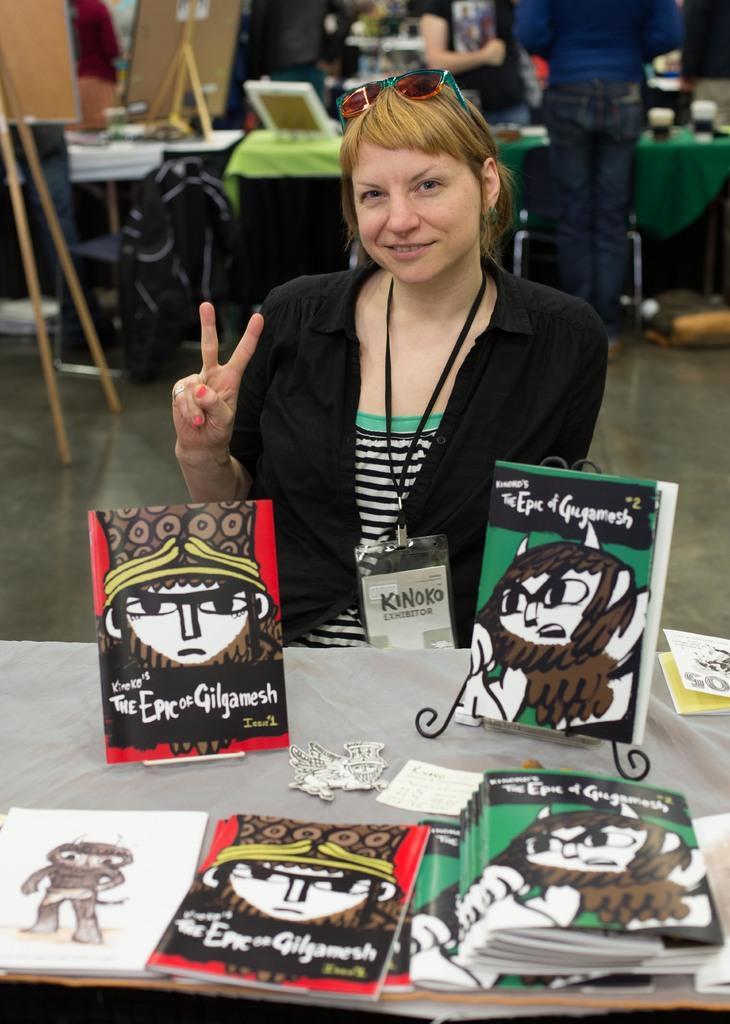Could you give a brief overview of what you see in this image? On the background of the picture we can see two persons standing in front of a table and these are boards and this is a floor. We can see here one women sitting and giving a pose to the camera. This is a table and on the table we can see boards. 